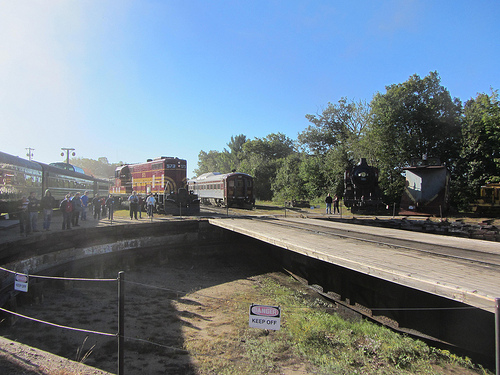How does the blue sky look like, stormy or clear? The blue sky in the image looks clear and bright. 